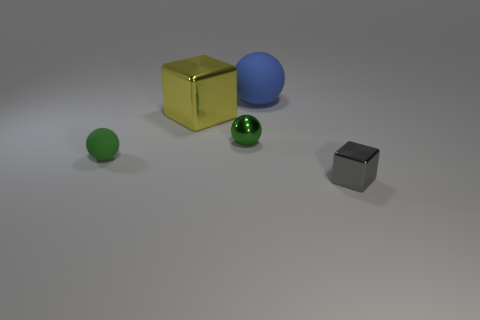Subtract all tiny metal spheres. How many spheres are left? 2 Subtract all yellow cylinders. How many green spheres are left? 2 Add 3 green things. How many objects exist? 8 Subtract all cyan balls. Subtract all cyan cylinders. How many balls are left? 3 Subtract all cubes. How many objects are left? 3 Subtract all tiny gray shiny blocks. Subtract all green rubber things. How many objects are left? 3 Add 1 big metal cubes. How many big metal cubes are left? 2 Add 4 small matte blocks. How many small matte blocks exist? 4 Subtract 0 purple cylinders. How many objects are left? 5 